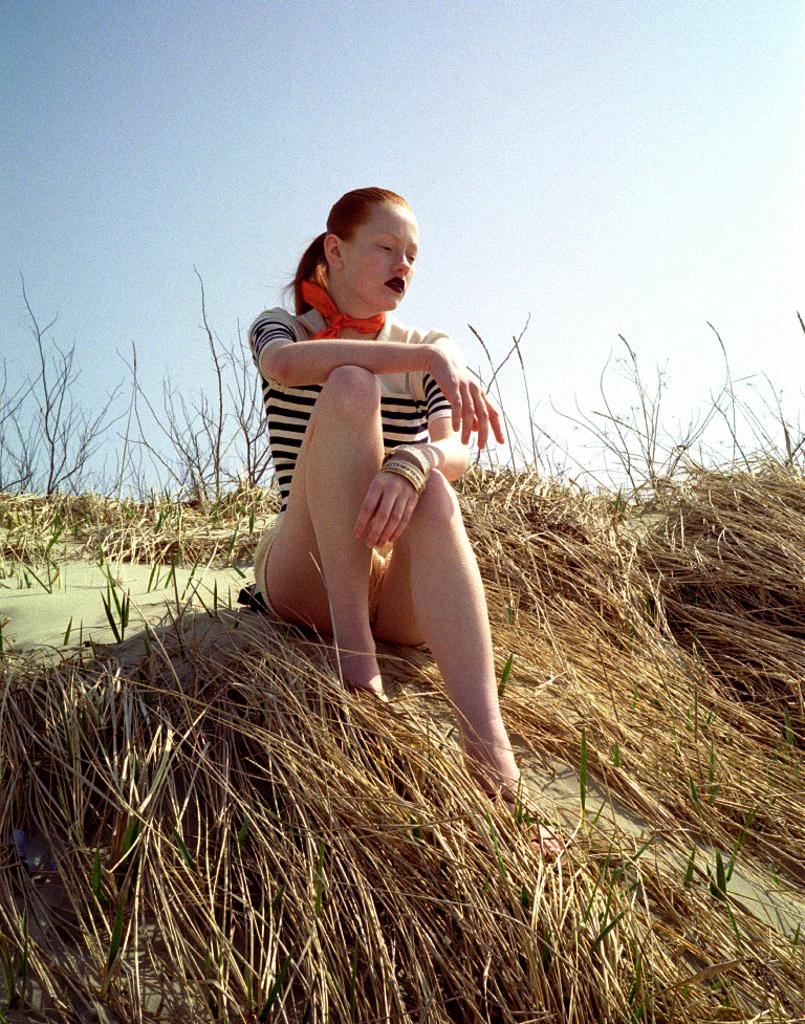Who is the main subject in the image? There is a lady in the image. What is the lady doing in the image? The lady is sitting on the grass. What can be seen in the background of the image? The sky is visible at the top of the image. What type of hands can be seen holding the bike in the image? There is no bike present in the image, so there are no hands holding a bike. 